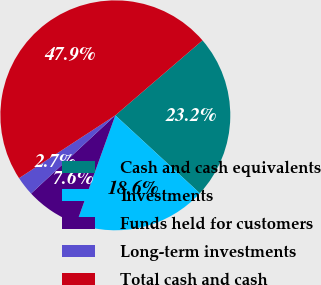<chart> <loc_0><loc_0><loc_500><loc_500><pie_chart><fcel>Cash and cash equivalents<fcel>Investments<fcel>Funds held for customers<fcel>Long-term investments<fcel>Total cash and cash<nl><fcel>23.16%<fcel>18.64%<fcel>7.59%<fcel>2.71%<fcel>47.89%<nl></chart> 